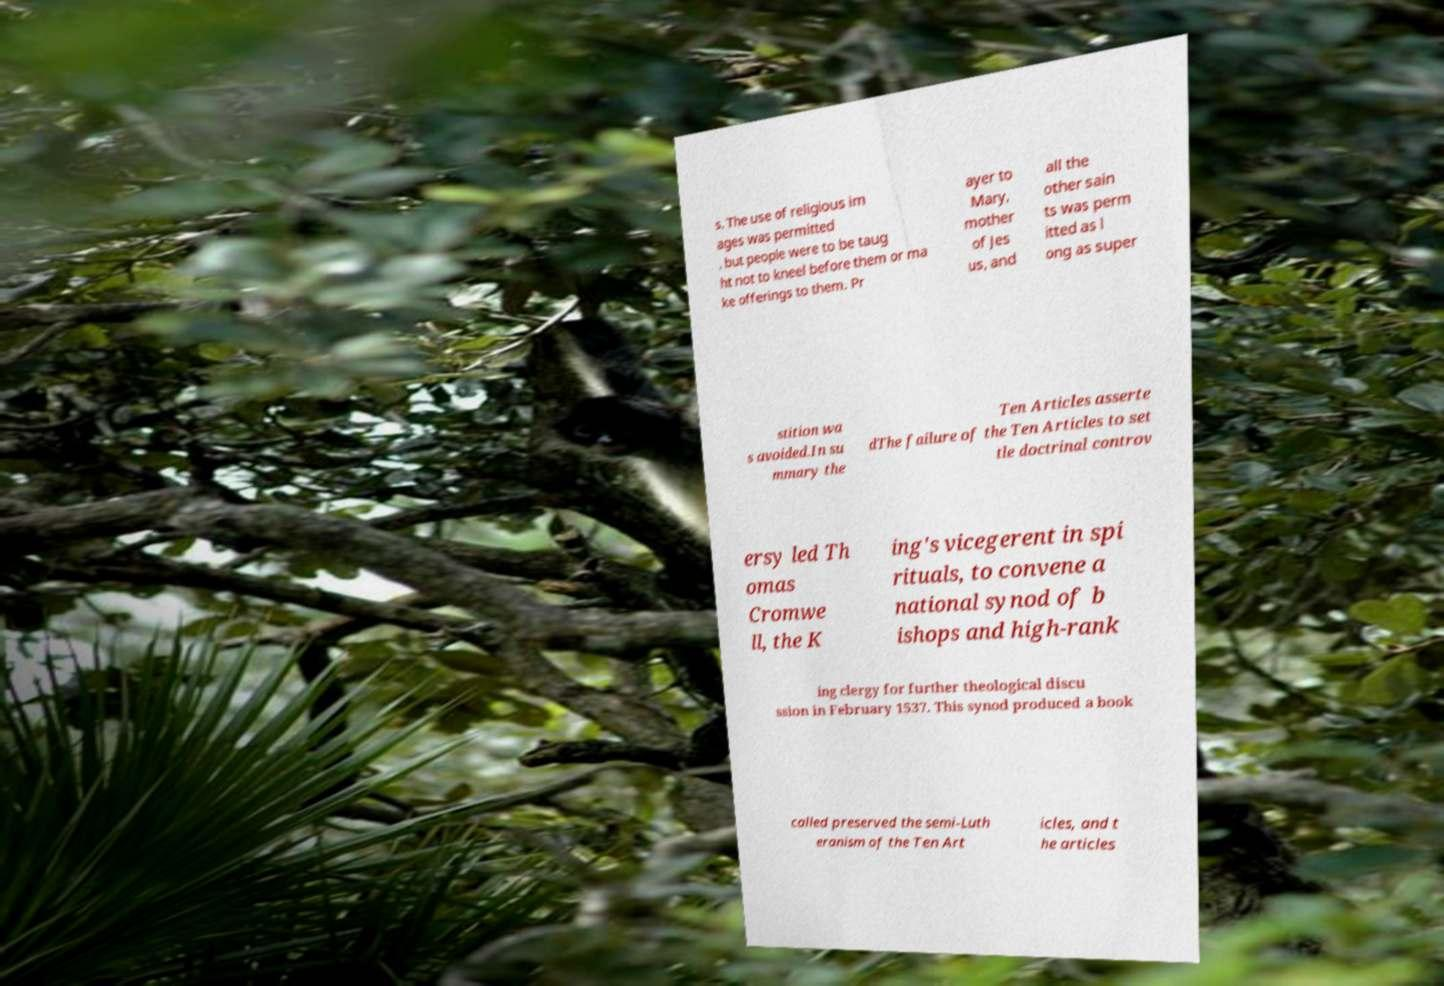Please identify and transcribe the text found in this image. s. The use of religious im ages was permitted , but people were to be taug ht not to kneel before them or ma ke offerings to them. Pr ayer to Mary, mother of Jes us, and all the other sain ts was perm itted as l ong as super stition wa s avoided.In su mmary the Ten Articles asserte dThe failure of the Ten Articles to set tle doctrinal controv ersy led Th omas Cromwe ll, the K ing's vicegerent in spi rituals, to convene a national synod of b ishops and high-rank ing clergy for further theological discu ssion in February 1537. This synod produced a book called preserved the semi-Luth eranism of the Ten Art icles, and t he articles 